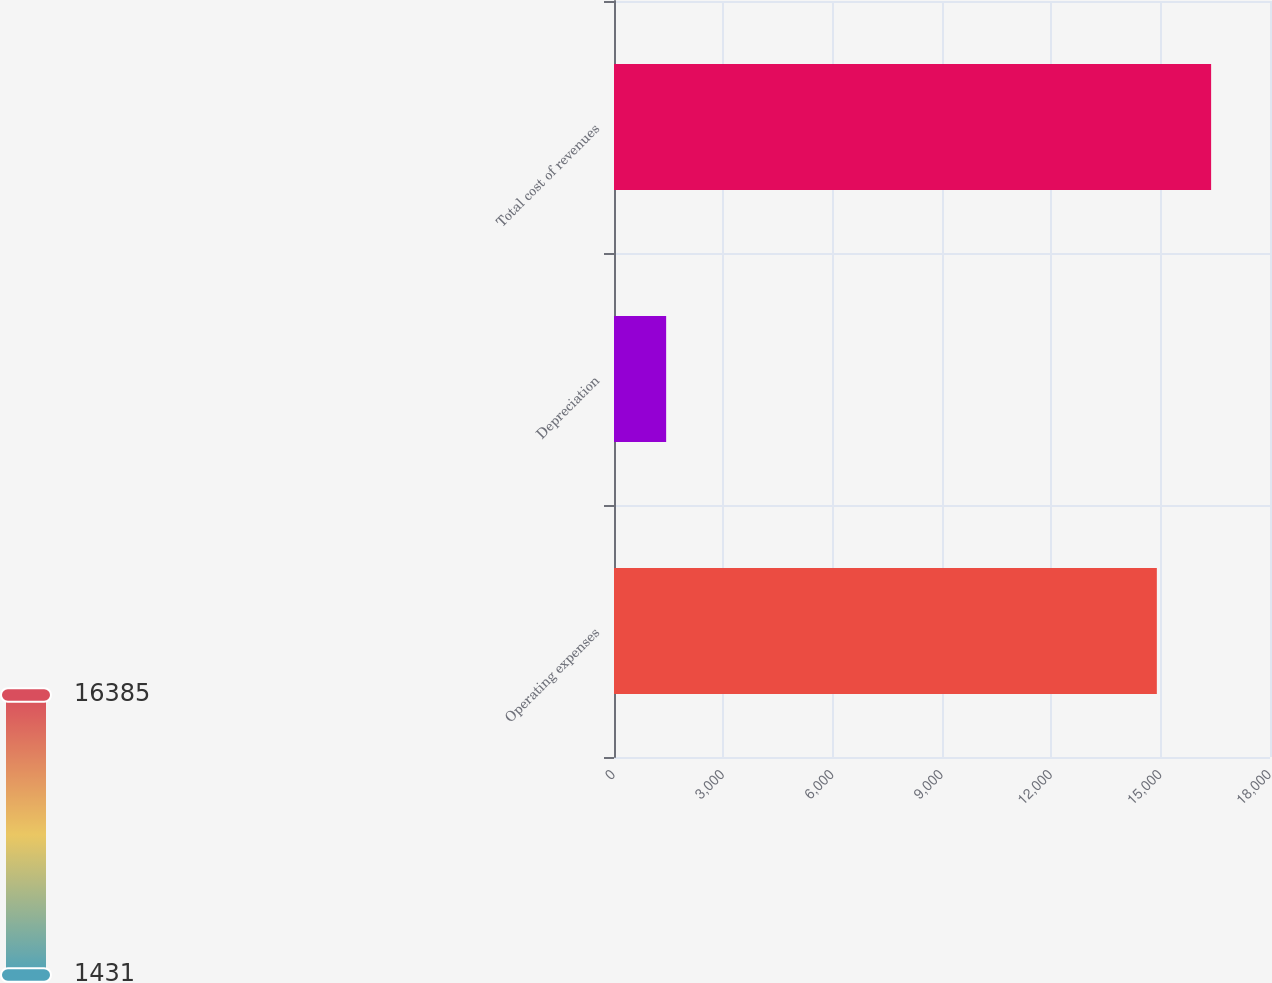Convert chart. <chart><loc_0><loc_0><loc_500><loc_500><bar_chart><fcel>Operating expenses<fcel>Depreciation<fcel>Total cost of revenues<nl><fcel>14895<fcel>1431<fcel>16384.5<nl></chart> 